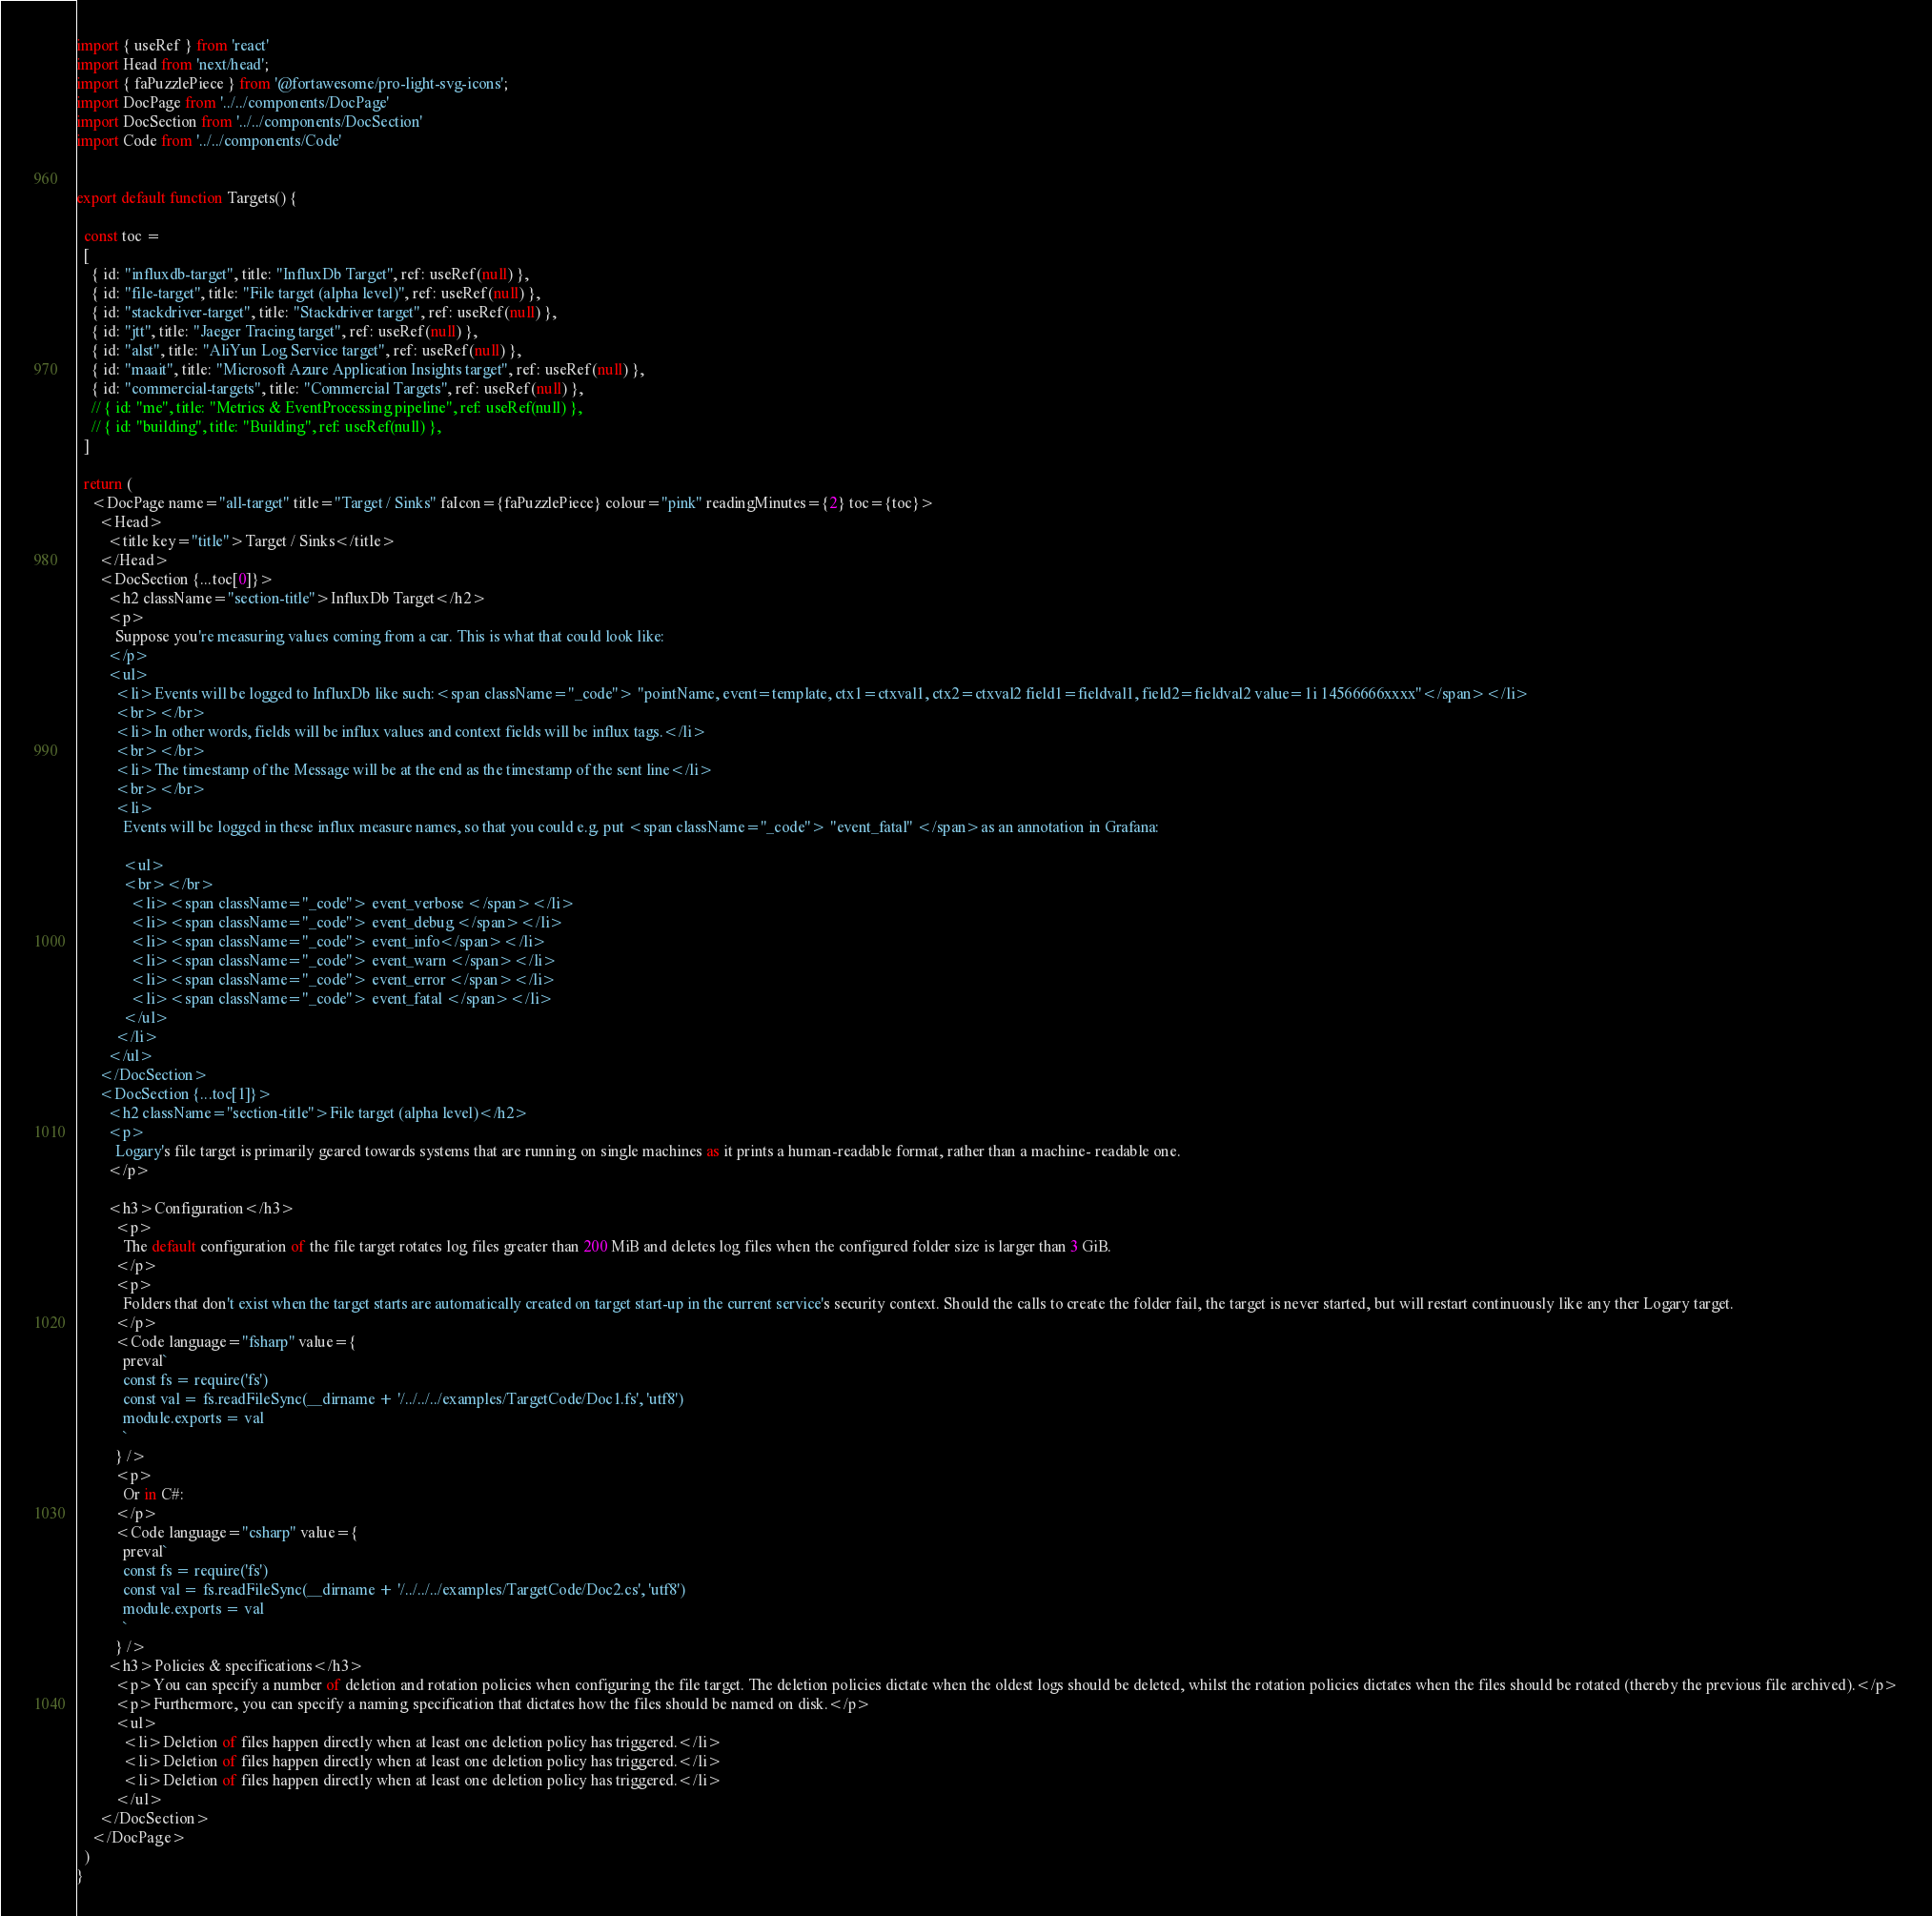<code> <loc_0><loc_0><loc_500><loc_500><_JavaScript_>
import { useRef } from 'react'
import Head from 'next/head';
import { faPuzzlePiece } from '@fortawesome/pro-light-svg-icons';
import DocPage from '../../components/DocPage'
import DocSection from '../../components/DocSection'
import Code from '../../components/Code'


export default function Targets() {

  const toc =
  [ 
    { id: "influxdb-target", title: "InfluxDb Target", ref: useRef(null) },
    { id: "file-target", title: "File target (alpha level)", ref: useRef(null) },
    { id: "stackdriver-target", title: "Stackdriver target", ref: useRef(null) },
    { id: "jtt", title: "Jaeger Tracing target", ref: useRef(null) },
    { id: "alst", title: "AliYun Log Service target", ref: useRef(null) },
    { id: "maait", title: "Microsoft Azure Application Insights target", ref: useRef(null) },
    { id: "commercial-targets", title: "Commercial Targets", ref: useRef(null) },
    // { id: "me", title: "Metrics & EventProcessing pipeline", ref: useRef(null) },
    // { id: "building", title: "Building", ref: useRef(null) },
  ]
  
  return (
    <DocPage name="all-target" title="Target / Sinks" faIcon={faPuzzlePiece} colour="pink" readingMinutes={2} toc={toc}>
      <Head>
        <title key="title">Target / Sinks</title>
      </Head>
      <DocSection {...toc[0]}>
        <h2 className="section-title">InfluxDb Target</h2>
        <p>
          Suppose you're measuring values coming from a car. This is what that could look like:
        </p> 
        <ul>
          <li>Events will be logged to InfluxDb like such:<span className="_code"> "pointName, event=template, ctx1=ctxval1, ctx2=ctxval2 field1=fieldval1, field2=fieldval2 value=1i 14566666xxxx"</span></li>
          <br></br>
          <li>In other words, fields will be influx values and context fields will be influx tags.</li>
          <br></br>
          <li>The timestamp of the Message will be at the end as the timestamp of the sent line</li>
          <br></br>
          <li>
            Events will be logged in these influx measure names, so that you could e.g. put <span className="_code"> "event_fatal" </span>as an annotation in Grafana:
            
            <ul>
            <br></br>
              <li><span className="_code"> event_verbose </span></li>
              <li><span className="_code"> event_debug </span></li>
              <li><span className="_code"> event_info</span></li>
              <li><span className="_code"> event_warn </span></li>
              <li><span className="_code"> event_error </span></li>
              <li><span className="_code"> event_fatal </span></li>
            </ul>
          </li>
        </ul>
      </DocSection>
      <DocSection {...toc[1]}>
        <h2 className="section-title">File target (alpha level)</h2>
        <p>
          Logary's file target is primarily geared towards systems that are running on single machines as it prints a human-readable format, rather than a machine- readable one.
        </p> 

        <h3>Configuration</h3>
          <p>
            The default configuration of the file target rotates log files greater than 200 MiB and deletes log files when the configured folder size is larger than 3 GiB.
          </p>
          <p>
            Folders that don't exist when the target starts are automatically created on target start-up in the current service's security context. Should the calls to create the folder fail, the target is never started, but will restart continuously like any ther Logary target.
          </p>
          <Code language="fsharp" value={
            preval`
            const fs = require('fs')
            const val = fs.readFileSync(__dirname + '/../../../examples/TargetCode/Doc1.fs', 'utf8')
            module.exports = val
            `
          } />
          <p>
            Or in C#:
          </p>
          <Code language="csharp" value={
            preval`
            const fs = require('fs')
            const val = fs.readFileSync(__dirname + '/../../../examples/TargetCode/Doc2.cs', 'utf8')
            module.exports = val
            `
          } />
        <h3>Policies & specifications</h3>
          <p>You can specify a number of deletion and rotation policies when configuring the file target. The deletion policies dictate when the oldest logs should be deleted, whilst the rotation policies dictates when the files should be rotated (thereby the previous file archived).</p>
          <p>Furthermore, you can specify a naming specification that dictates how the files should be named on disk.</p>
          <ul>
            <li>Deletion of files happen directly when at least one deletion policy has triggered.</li>
            <li>Deletion of files happen directly when at least one deletion policy has triggered.</li>
            <li>Deletion of files happen directly when at least one deletion policy has triggered.</li>
          </ul>
      </DocSection>
    </DocPage>
  )
}</code> 